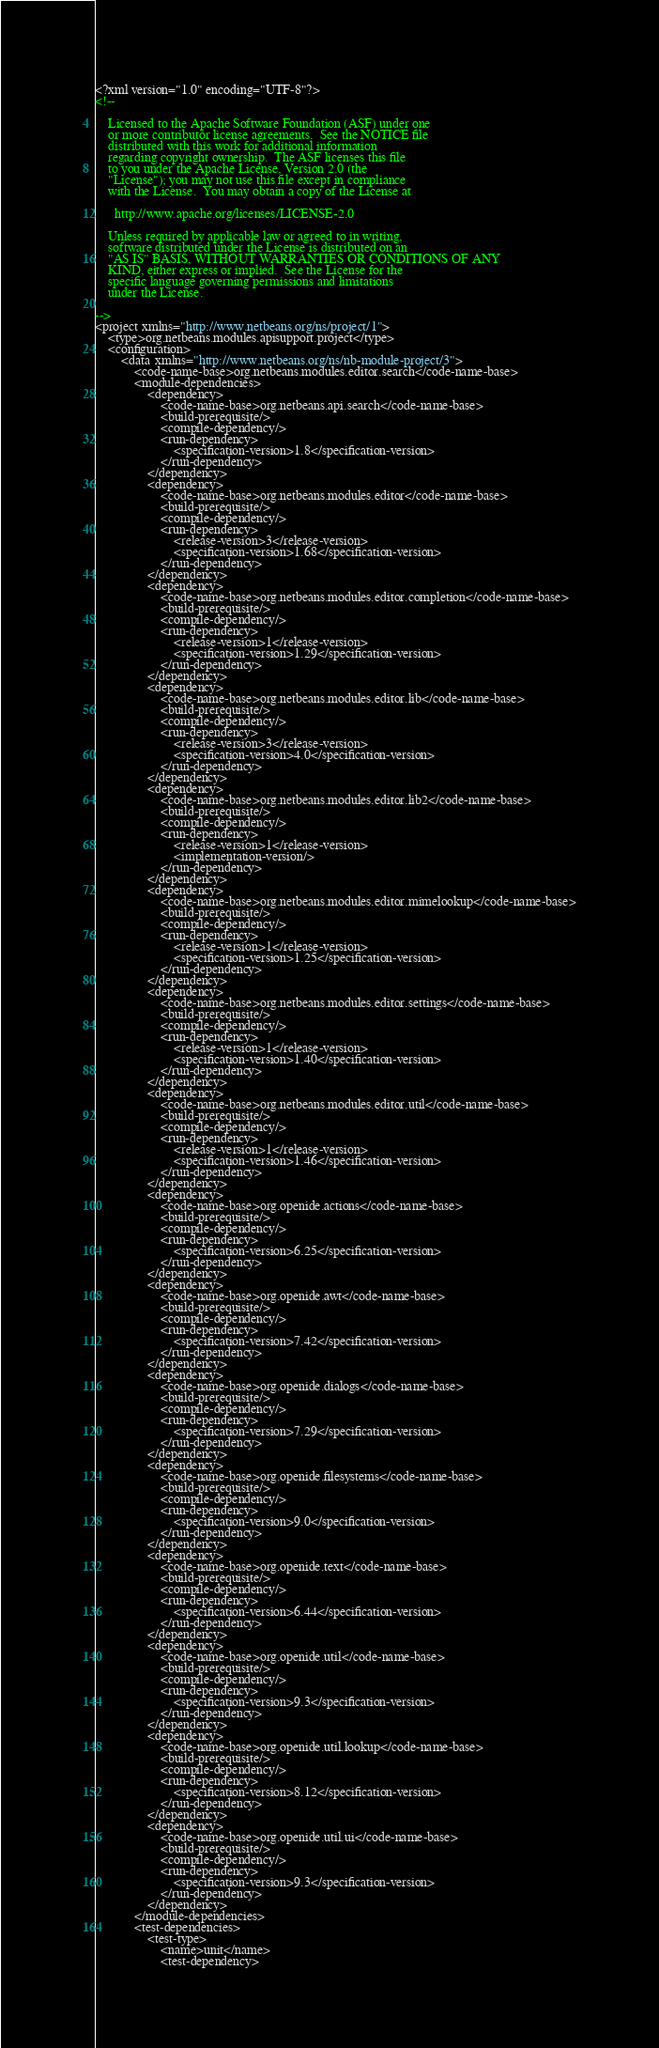Convert code to text. <code><loc_0><loc_0><loc_500><loc_500><_XML_><?xml version="1.0" encoding="UTF-8"?>
<!--

    Licensed to the Apache Software Foundation (ASF) under one
    or more contributor license agreements.  See the NOTICE file
    distributed with this work for additional information
    regarding copyright ownership.  The ASF licenses this file
    to you under the Apache License, Version 2.0 (the
    "License"); you may not use this file except in compliance
    with the License.  You may obtain a copy of the License at

      http://www.apache.org/licenses/LICENSE-2.0

    Unless required by applicable law or agreed to in writing,
    software distributed under the License is distributed on an
    "AS IS" BASIS, WITHOUT WARRANTIES OR CONDITIONS OF ANY
    KIND, either express or implied.  See the License for the
    specific language governing permissions and limitations
    under the License.

-->
<project xmlns="http://www.netbeans.org/ns/project/1">
    <type>org.netbeans.modules.apisupport.project</type>
    <configuration>
        <data xmlns="http://www.netbeans.org/ns/nb-module-project/3">
            <code-name-base>org.netbeans.modules.editor.search</code-name-base>
            <module-dependencies>
                <dependency>
                    <code-name-base>org.netbeans.api.search</code-name-base>
                    <build-prerequisite/>
                    <compile-dependency/>
                    <run-dependency>
                        <specification-version>1.8</specification-version>
                    </run-dependency>
                </dependency>
                <dependency>
                    <code-name-base>org.netbeans.modules.editor</code-name-base>
                    <build-prerequisite/>
                    <compile-dependency/>
                    <run-dependency>
                        <release-version>3</release-version>
                        <specification-version>1.68</specification-version>
                    </run-dependency>
                </dependency>
                <dependency>
                    <code-name-base>org.netbeans.modules.editor.completion</code-name-base>
                    <build-prerequisite/>
                    <compile-dependency/>
                    <run-dependency>
                        <release-version>1</release-version>
                        <specification-version>1.29</specification-version>
                    </run-dependency>
                </dependency>
                <dependency>
                    <code-name-base>org.netbeans.modules.editor.lib</code-name-base>
                    <build-prerequisite/>
                    <compile-dependency/>
                    <run-dependency>
                        <release-version>3</release-version>
                        <specification-version>4.0</specification-version>
                    </run-dependency>
                </dependency>
                <dependency>
                    <code-name-base>org.netbeans.modules.editor.lib2</code-name-base>
                    <build-prerequisite/>
                    <compile-dependency/>
                    <run-dependency>
                        <release-version>1</release-version>
                        <implementation-version/>
                    </run-dependency>
                </dependency>
                <dependency>
                    <code-name-base>org.netbeans.modules.editor.mimelookup</code-name-base>
                    <build-prerequisite/>
                    <compile-dependency/>
                    <run-dependency>
                        <release-version>1</release-version>
                        <specification-version>1.25</specification-version>
                    </run-dependency>
                </dependency>
                <dependency>
                    <code-name-base>org.netbeans.modules.editor.settings</code-name-base>
                    <build-prerequisite/>
                    <compile-dependency/>
                    <run-dependency>
                        <release-version>1</release-version>
                        <specification-version>1.40</specification-version>
                    </run-dependency>
                </dependency>
                <dependency>
                    <code-name-base>org.netbeans.modules.editor.util</code-name-base>
                    <build-prerequisite/>
                    <compile-dependency/>
                    <run-dependency>
                        <release-version>1</release-version>
                        <specification-version>1.46</specification-version>
                    </run-dependency>
                </dependency>
                <dependency>
                    <code-name-base>org.openide.actions</code-name-base>
                    <build-prerequisite/>
                    <compile-dependency/>
                    <run-dependency>
                        <specification-version>6.25</specification-version>
                    </run-dependency>
                </dependency>
                <dependency>
                    <code-name-base>org.openide.awt</code-name-base>
                    <build-prerequisite/>
                    <compile-dependency/>
                    <run-dependency>
                        <specification-version>7.42</specification-version>
                    </run-dependency>
                </dependency>
                <dependency>
                    <code-name-base>org.openide.dialogs</code-name-base>
                    <build-prerequisite/>
                    <compile-dependency/>
                    <run-dependency>
                        <specification-version>7.29</specification-version>
                    </run-dependency>
                </dependency>
                <dependency>
                    <code-name-base>org.openide.filesystems</code-name-base>
                    <build-prerequisite/>
                    <compile-dependency/>
                    <run-dependency>
                        <specification-version>9.0</specification-version>
                    </run-dependency>
                </dependency>
                <dependency>
                    <code-name-base>org.openide.text</code-name-base>
                    <build-prerequisite/>
                    <compile-dependency/>
                    <run-dependency>
                        <specification-version>6.44</specification-version>
                    </run-dependency>
                </dependency>
                <dependency>
                    <code-name-base>org.openide.util</code-name-base>
                    <build-prerequisite/>
                    <compile-dependency/>
                    <run-dependency>
                        <specification-version>9.3</specification-version>
                    </run-dependency>
                </dependency>
                <dependency>
                    <code-name-base>org.openide.util.lookup</code-name-base>
                    <build-prerequisite/>
                    <compile-dependency/>
                    <run-dependency>
                        <specification-version>8.12</specification-version>
                    </run-dependency>
                </dependency>
                <dependency>
                    <code-name-base>org.openide.util.ui</code-name-base>
                    <build-prerequisite/>
                    <compile-dependency/>
                    <run-dependency>
                        <specification-version>9.3</specification-version>
                    </run-dependency>
                </dependency>
            </module-dependencies>
            <test-dependencies>
                <test-type>
                    <name>unit</name>
                    <test-dependency></code> 